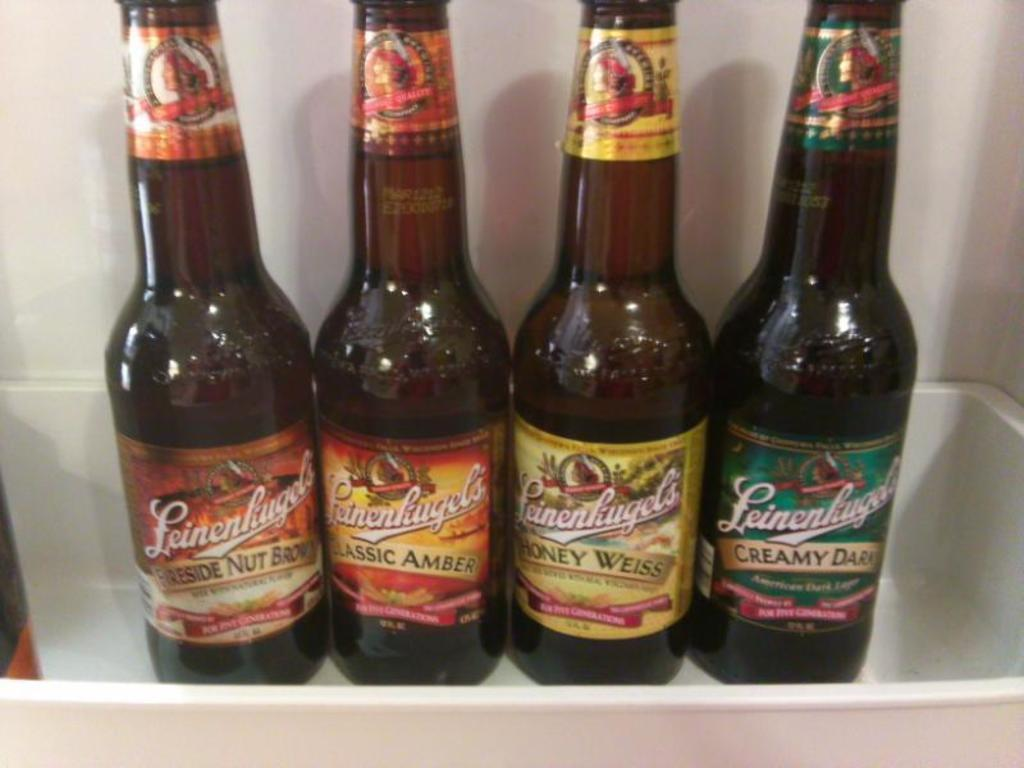<image>
Share a concise interpretation of the image provided. Four bottles of Leinenkugels ale in the refrigerator. 